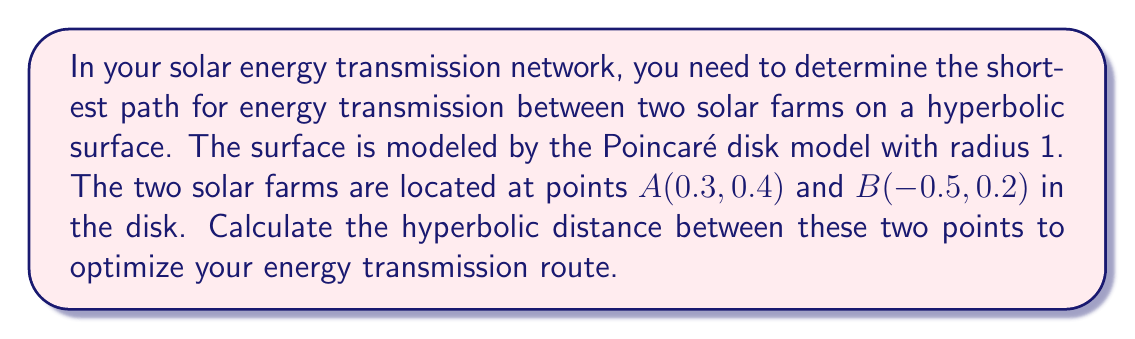What is the answer to this math problem? To solve this problem, we'll follow these steps:

1) In the Poincaré disk model, the hyperbolic distance $d$ between two points $(x_1, y_1)$ and $(x_2, y_2)$ is given by:

   $$d = \text{arcosh}\left(1 + \frac{2|z_1 - z_2|^2}{(1-|z_1|^2)(1-|z_2|^2)}\right)$$

   where $z_1 = x_1 + iy_1$ and $z_2 = x_2 + iy_2$ are the complex representations of the points.

2) For point A: $z_1 = 0.3 + 0.4i$
   For point B: $z_2 = -0.5 + 0.2i$

3) Calculate $|z_1 - z_2|^2$:
   $$|z_1 - z_2|^2 = (0.3 - (-0.5))^2 + (0.4 - 0.2)^2 = 0.8^2 + 0.2^2 = 0.68$$

4) Calculate $|z_1|^2$ and $|z_2|^2$:
   $$|z_1|^2 = 0.3^2 + 0.4^2 = 0.25$$
   $$|z_2|^2 = (-0.5)^2 + 0.2^2 = 0.29$$

5) Substitute into the formula:
   $$d = \text{arcosh}\left(1 + \frac{2(0.68)}{(1-0.25)(1-0.29)}\right)$$
   $$d = \text{arcosh}\left(1 + \frac{1.36}{0.75 \cdot 0.71}\right)$$
   $$d = \text{arcosh}\left(1 + \frac{1.36}{0.5325}\right)$$
   $$d = \text{arcosh}(3.5533)$$

6) Calculate the final result:
   $$d \approx 1.9179$$

This value represents the shortest path (geodesic) between the two solar farms on the hyperbolic surface.
Answer: $1.9179$ 